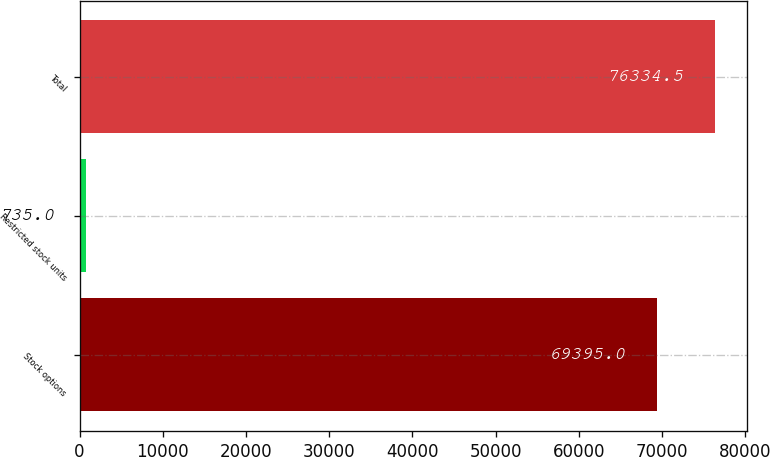Convert chart to OTSL. <chart><loc_0><loc_0><loc_500><loc_500><bar_chart><fcel>Stock options<fcel>Restricted stock units<fcel>Total<nl><fcel>69395<fcel>735<fcel>76334.5<nl></chart> 